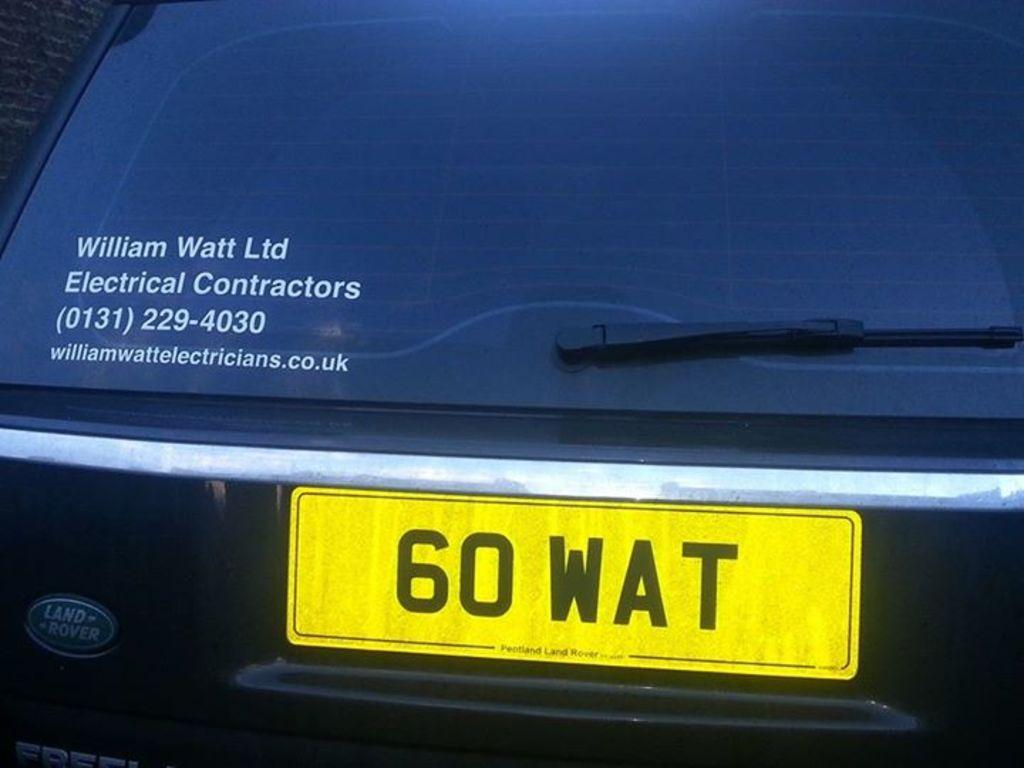What is the main subject of the image? The main subject of the image is a car boot. Are there any words or letters on the car boot? Yes, there is text on the car boot. What else can be seen in the image related to the car? There is a number plate in the image. What type of argument is taking place in the image? There is no argument present in the image; it only features a car boot with text and a number plate. What hobbies are the people in the image engaged in? There are no people visible in the image, so their hobbies cannot be determined. 